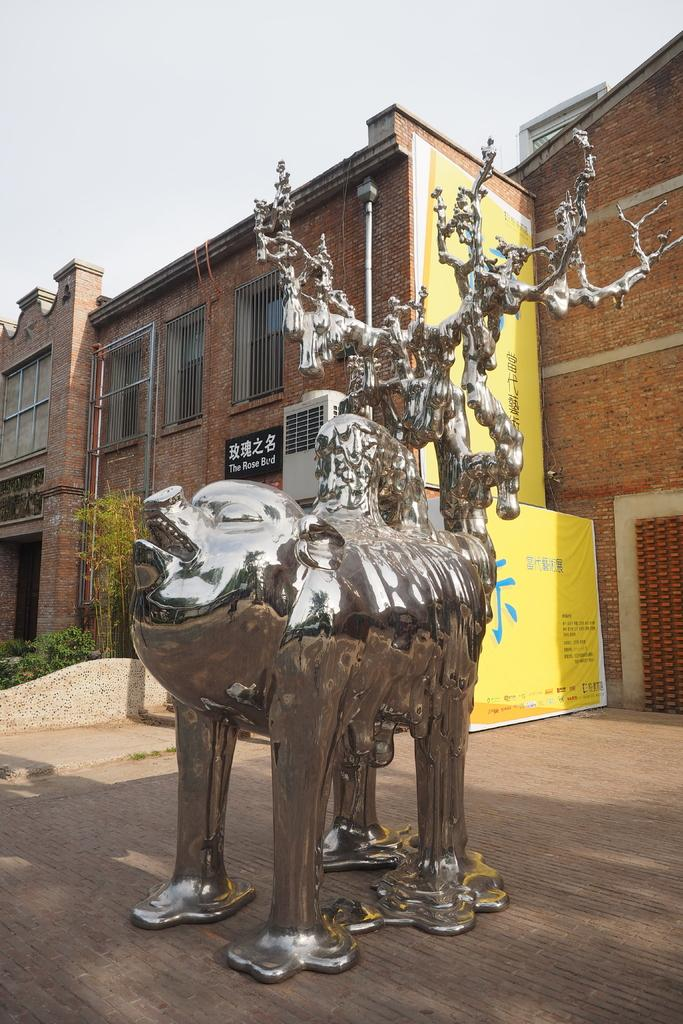What is the main subject of the image? There is a statue in the image. Where is the statue located? The statue is placed on the road. What can be seen in the background of the image? There is a building in the background of the image. What is visible at the top of the image? The sky is visible at the top of the image. What type of science experiment is being conducted on the statue in the image? There is no science experiment being conducted on the statue in the image. 